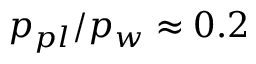<formula> <loc_0><loc_0><loc_500><loc_500>p _ { p l } / p _ { w } \approx 0 . 2</formula> 